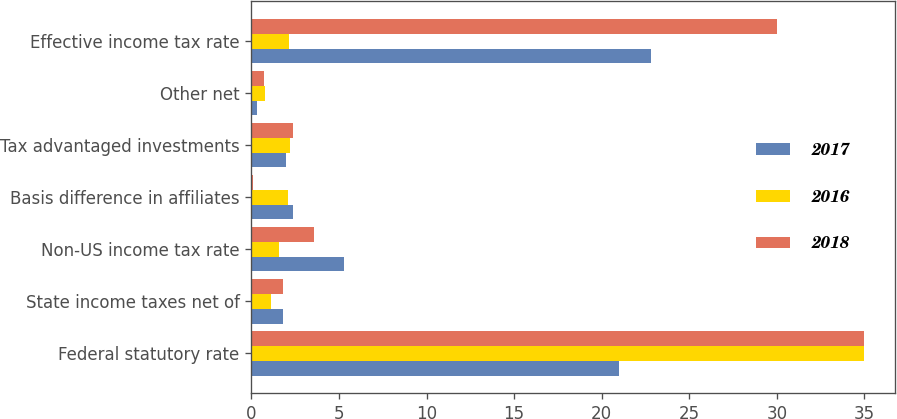Convert chart to OTSL. <chart><loc_0><loc_0><loc_500><loc_500><stacked_bar_chart><ecel><fcel>Federal statutory rate<fcel>State income taxes net of<fcel>Non-US income tax rate<fcel>Basis difference in affiliates<fcel>Tax advantaged investments<fcel>Other net<fcel>Effective income tax rate<nl><fcel>2017<fcel>21<fcel>1.8<fcel>5.3<fcel>2.4<fcel>2<fcel>0.3<fcel>22.8<nl><fcel>2016<fcel>35<fcel>1.1<fcel>1.6<fcel>2.1<fcel>2.2<fcel>0.8<fcel>2.15<nl><fcel>2018<fcel>35<fcel>1.8<fcel>3.6<fcel>0.1<fcel>2.4<fcel>0.7<fcel>30<nl></chart> 